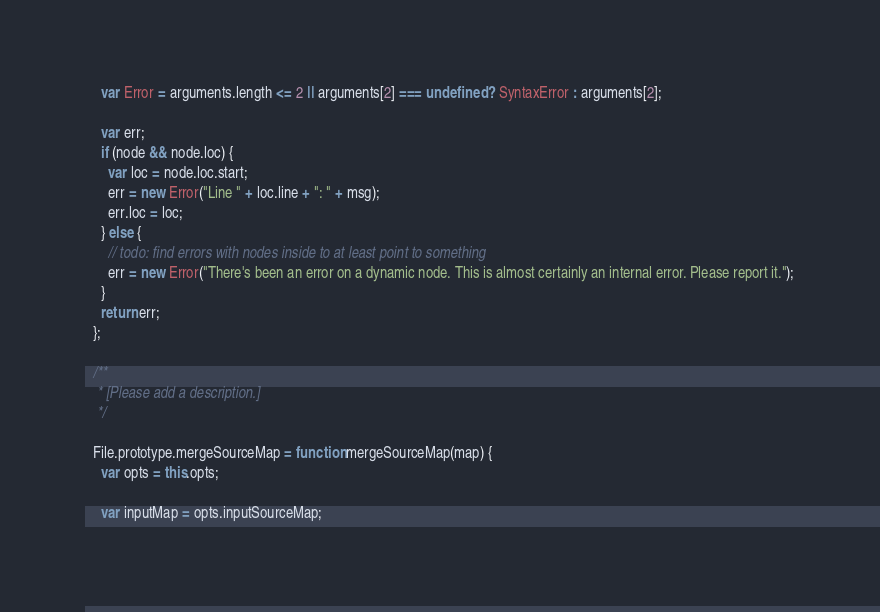<code> <loc_0><loc_0><loc_500><loc_500><_JavaScript_>    var Error = arguments.length <= 2 || arguments[2] === undefined ? SyntaxError : arguments[2];

    var err;
    if (node && node.loc) {
      var loc = node.loc.start;
      err = new Error("Line " + loc.line + ": " + msg);
      err.loc = loc;
    } else {
      // todo: find errors with nodes inside to at least point to something
      err = new Error("There's been an error on a dynamic node. This is almost certainly an internal error. Please report it.");
    }
    return err;
  };

  /**
   * [Please add a description.]
   */

  File.prototype.mergeSourceMap = function mergeSourceMap(map) {
    var opts = this.opts;

    var inputMap = opts.inputSourceMap;
</code> 